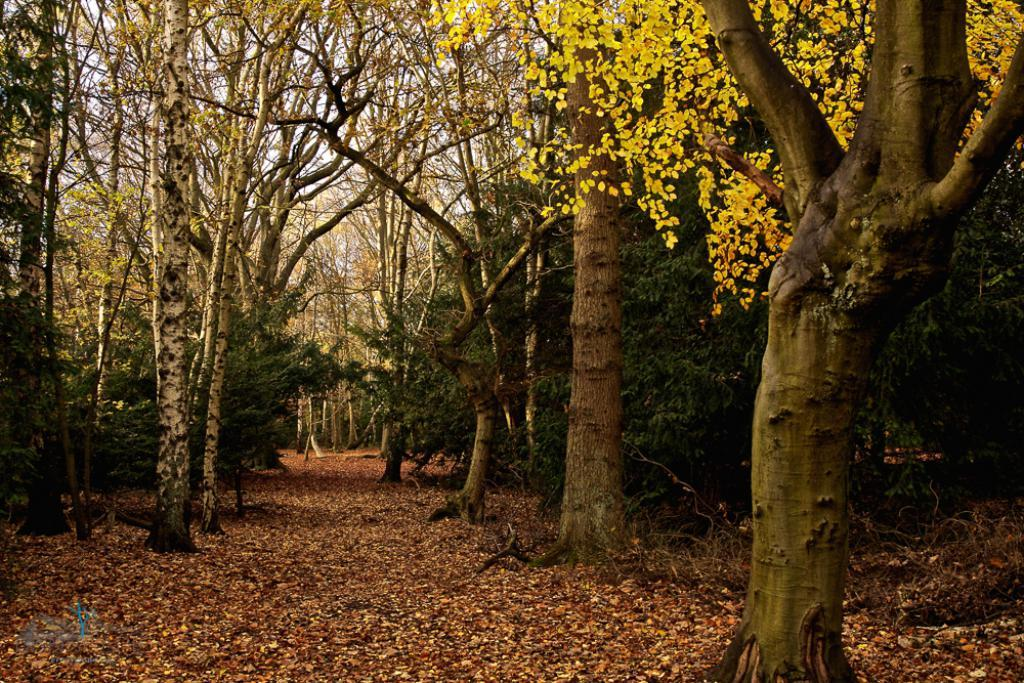What type of vegetation can be seen in the image? There are trees in the image. What is present on the surface in the image? Dry leaves are present on the surface in the image. What type of prose is being written with the pen in the image? There is no pen or prose present in the image; it only features trees and dry leaves. 